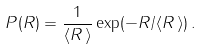<formula> <loc_0><loc_0><loc_500><loc_500>P ( R ) = \frac { 1 } { \langle R \, \rangle } \exp ( - R / \langle R \, \rangle ) \, .</formula> 